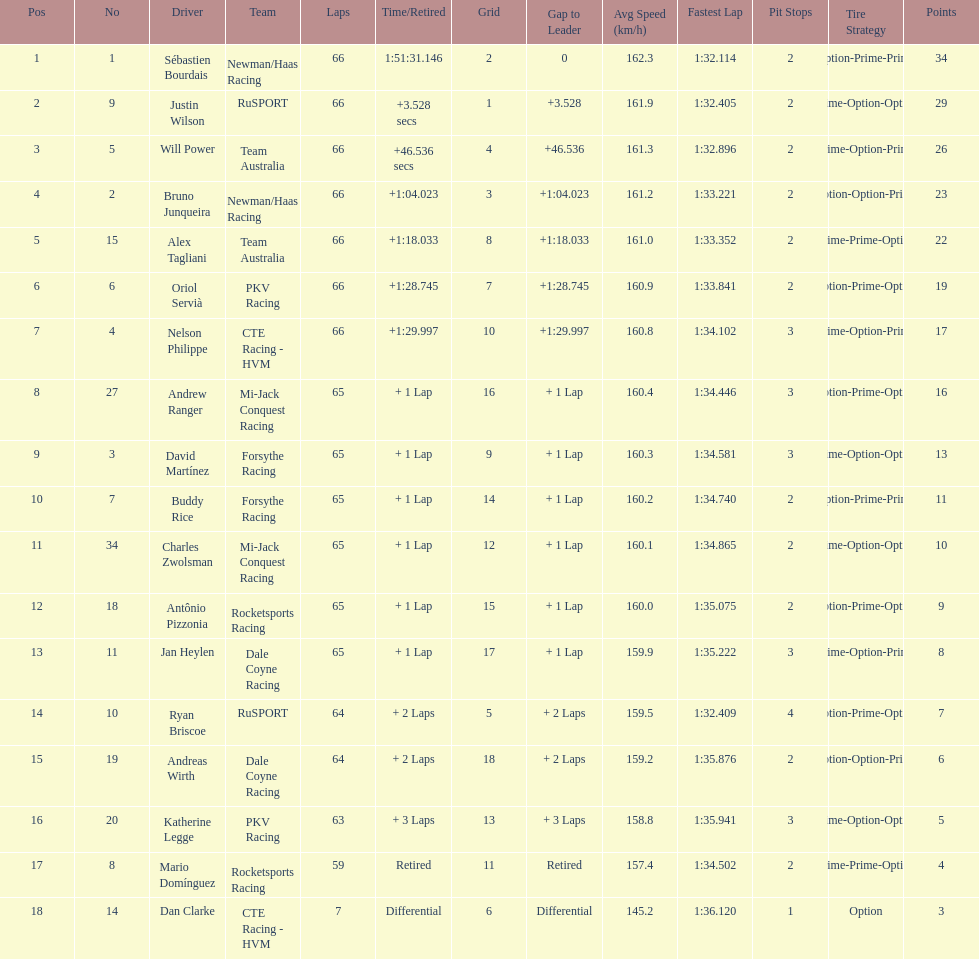Which country is represented by the most drivers? United Kingdom. 